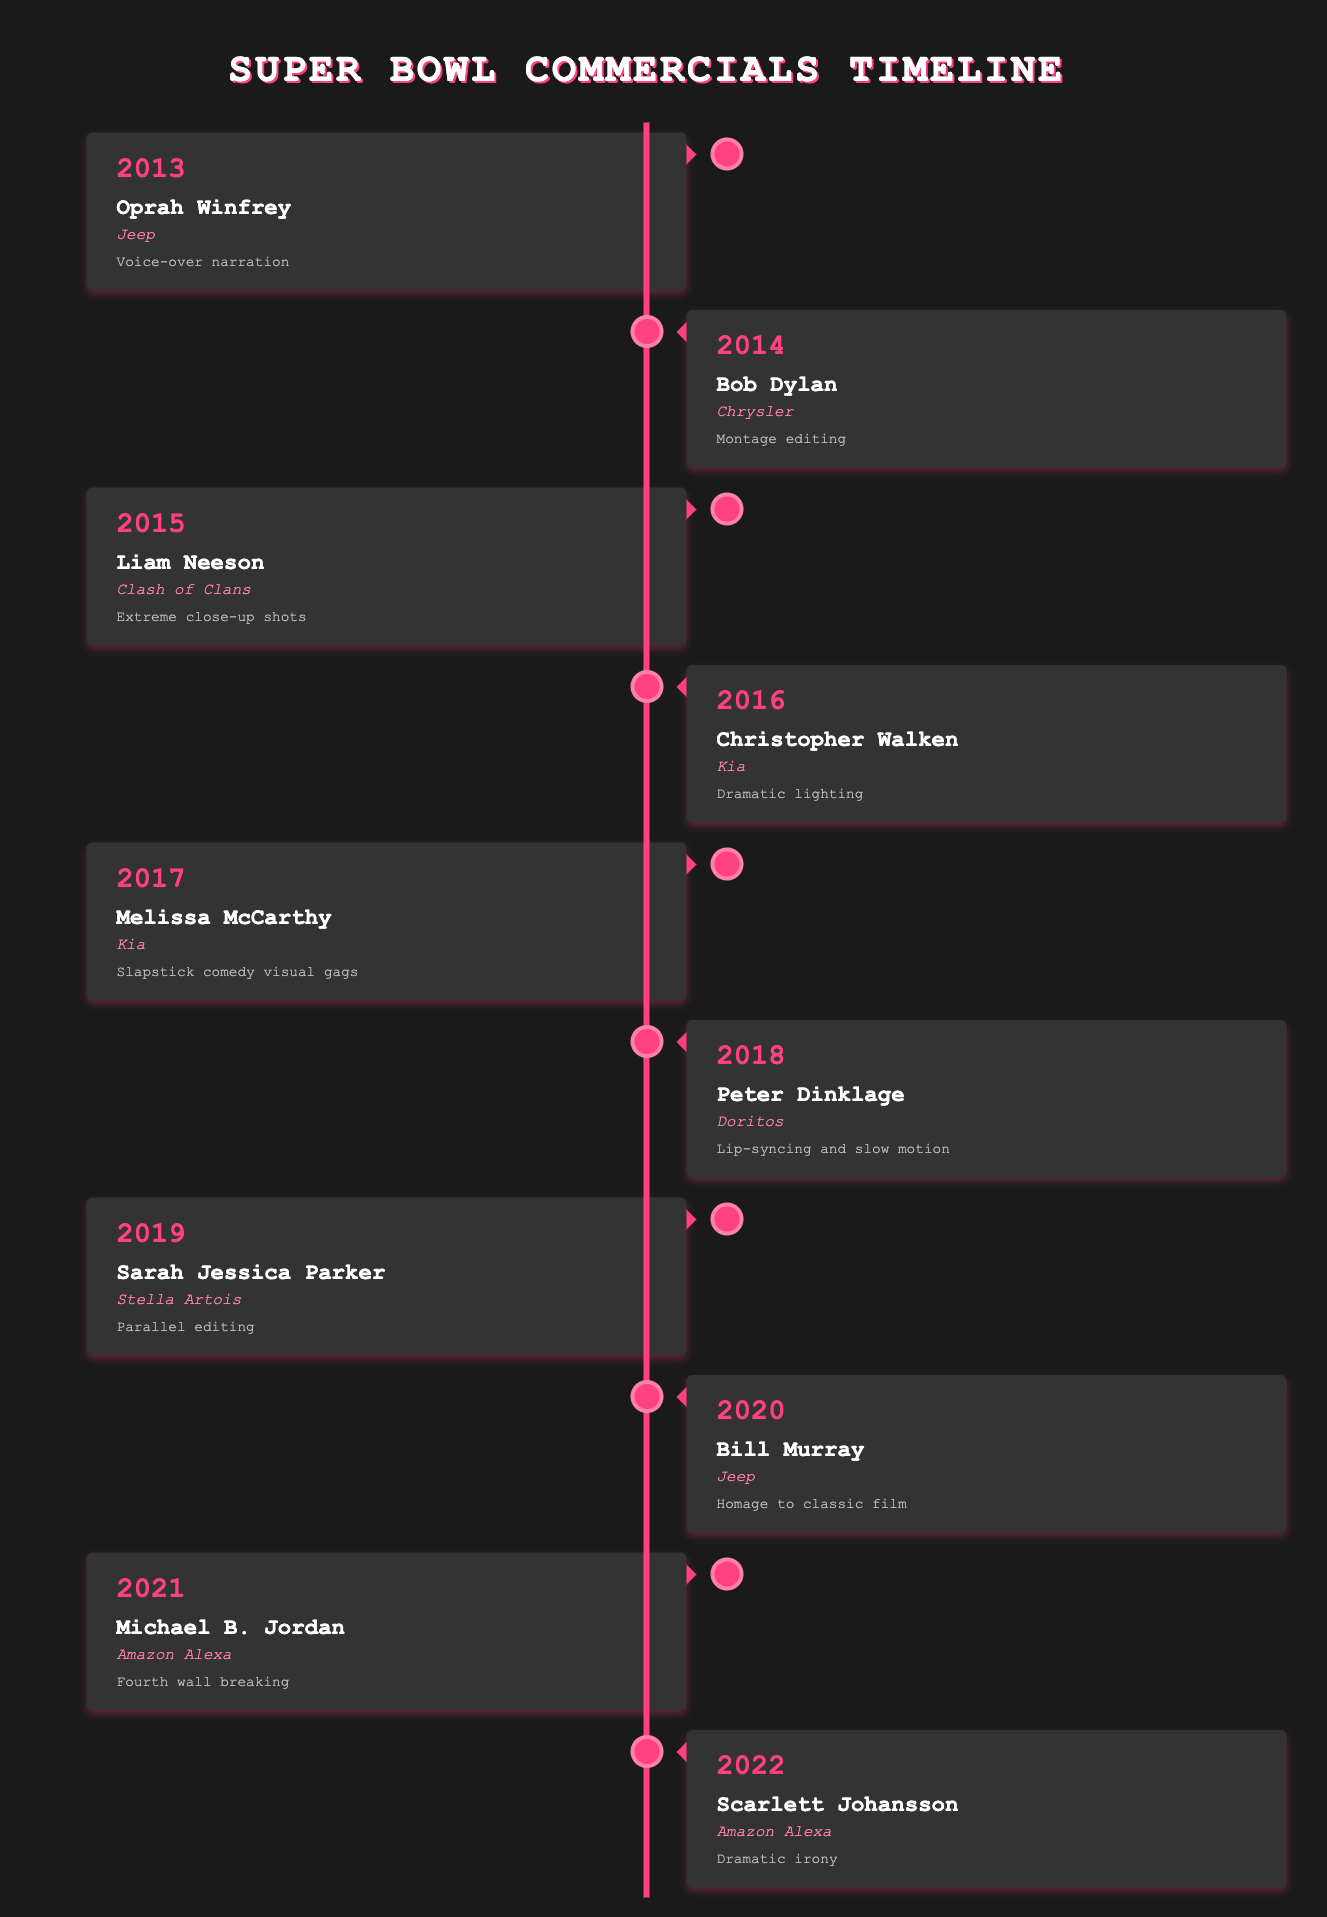What brand did Oprah Winfrey represent in 2013? According to the table, in the year 2013, Oprah Winfrey appeared in a commercial for the brand Jeep.
Answer: Jeep Which celebrity appeared in a Super Bowl ad for Amazon Alexa? The table shows two celebrities associated with Amazon Alexa: Michael B. Jordan in 2021 and Scarlett Johansson in 2022.
Answer: Michael B. Jordan and Scarlett Johansson How many times did Kia work with celebrities in this timeline? The table shows that Kia collaborated with Christopher Walken in 2016 and Melissa McCarthy in 2017, totaling two appearances.
Answer: 2 What cinematic technique was used in Bob Dylan's commercial for Chrysler? The timeline specifies that Bob Dylan's commercial for Chrysler in 2014 utilized montage editing as the cinematic technique.
Answer: Montage editing Did any celebrity from the 2020 list have a direct homage to classic films in their Super Bowl ad? Yes, Bill Murray's 2020 Super Bowl ad for Jeep featured an homage to classic films according to the data.
Answer: Yes Which year had the most recent celebrity appearance in the table, and what technique was utilized? The most recent year listed in the table is 2022, in which Scarlett Johansson appeared in an Amazon Alexa ad, employing the technique of dramatic irony.
Answer: 2022, dramatic irony What is the average number of years between celebrity appearances in Super Bowl ads from 2013 to 2022? Counting the years from 2013 to 2022 gives us 10 years, with 10 listed appearances in that time. Therefore, the average interval between appearances is calculated as 10 years / 10 ads = 1 year per appearance.
Answer: 1 year Which celebrity's commercial featured dramatic lighting as a cinematic technique? According to the table, Christopher Walken's commercial for Kia in 2016 featured dramatic lighting as its cinematic technique.
Answer: Christopher Walken Was there any Super Bowl commercial from this list that utilized slapstick comedy visual gags? Yes, the 2017 ad featuring Melissa McCarthy for Kia used slapstick comedy visual gags as noted in the timeline.
Answer: Yes 